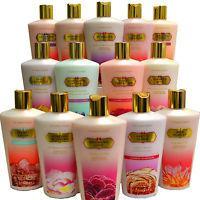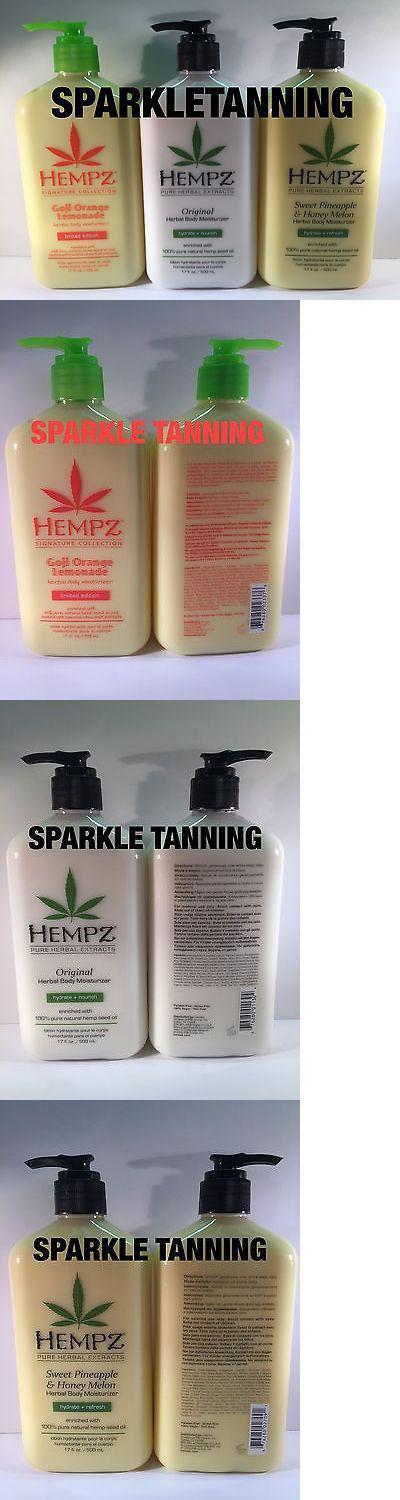The first image is the image on the left, the second image is the image on the right. Analyze the images presented: Is the assertion "Product is in travel, plastic packages rather than bottles." valid? Answer yes or no. No. 